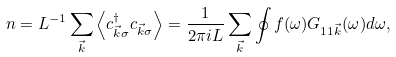Convert formula to latex. <formula><loc_0><loc_0><loc_500><loc_500>n = L ^ { - 1 } \sum _ { \vec { k } } \left < c _ { \vec { k } \sigma } ^ { \dagger } c _ { \vec { k } \sigma } \right > = \frac { 1 } { 2 \pi i L } \sum _ { \vec { k } } \oint f ( \omega ) G _ { 1 1 \vec { k } } ( \omega ) d \omega ,</formula> 